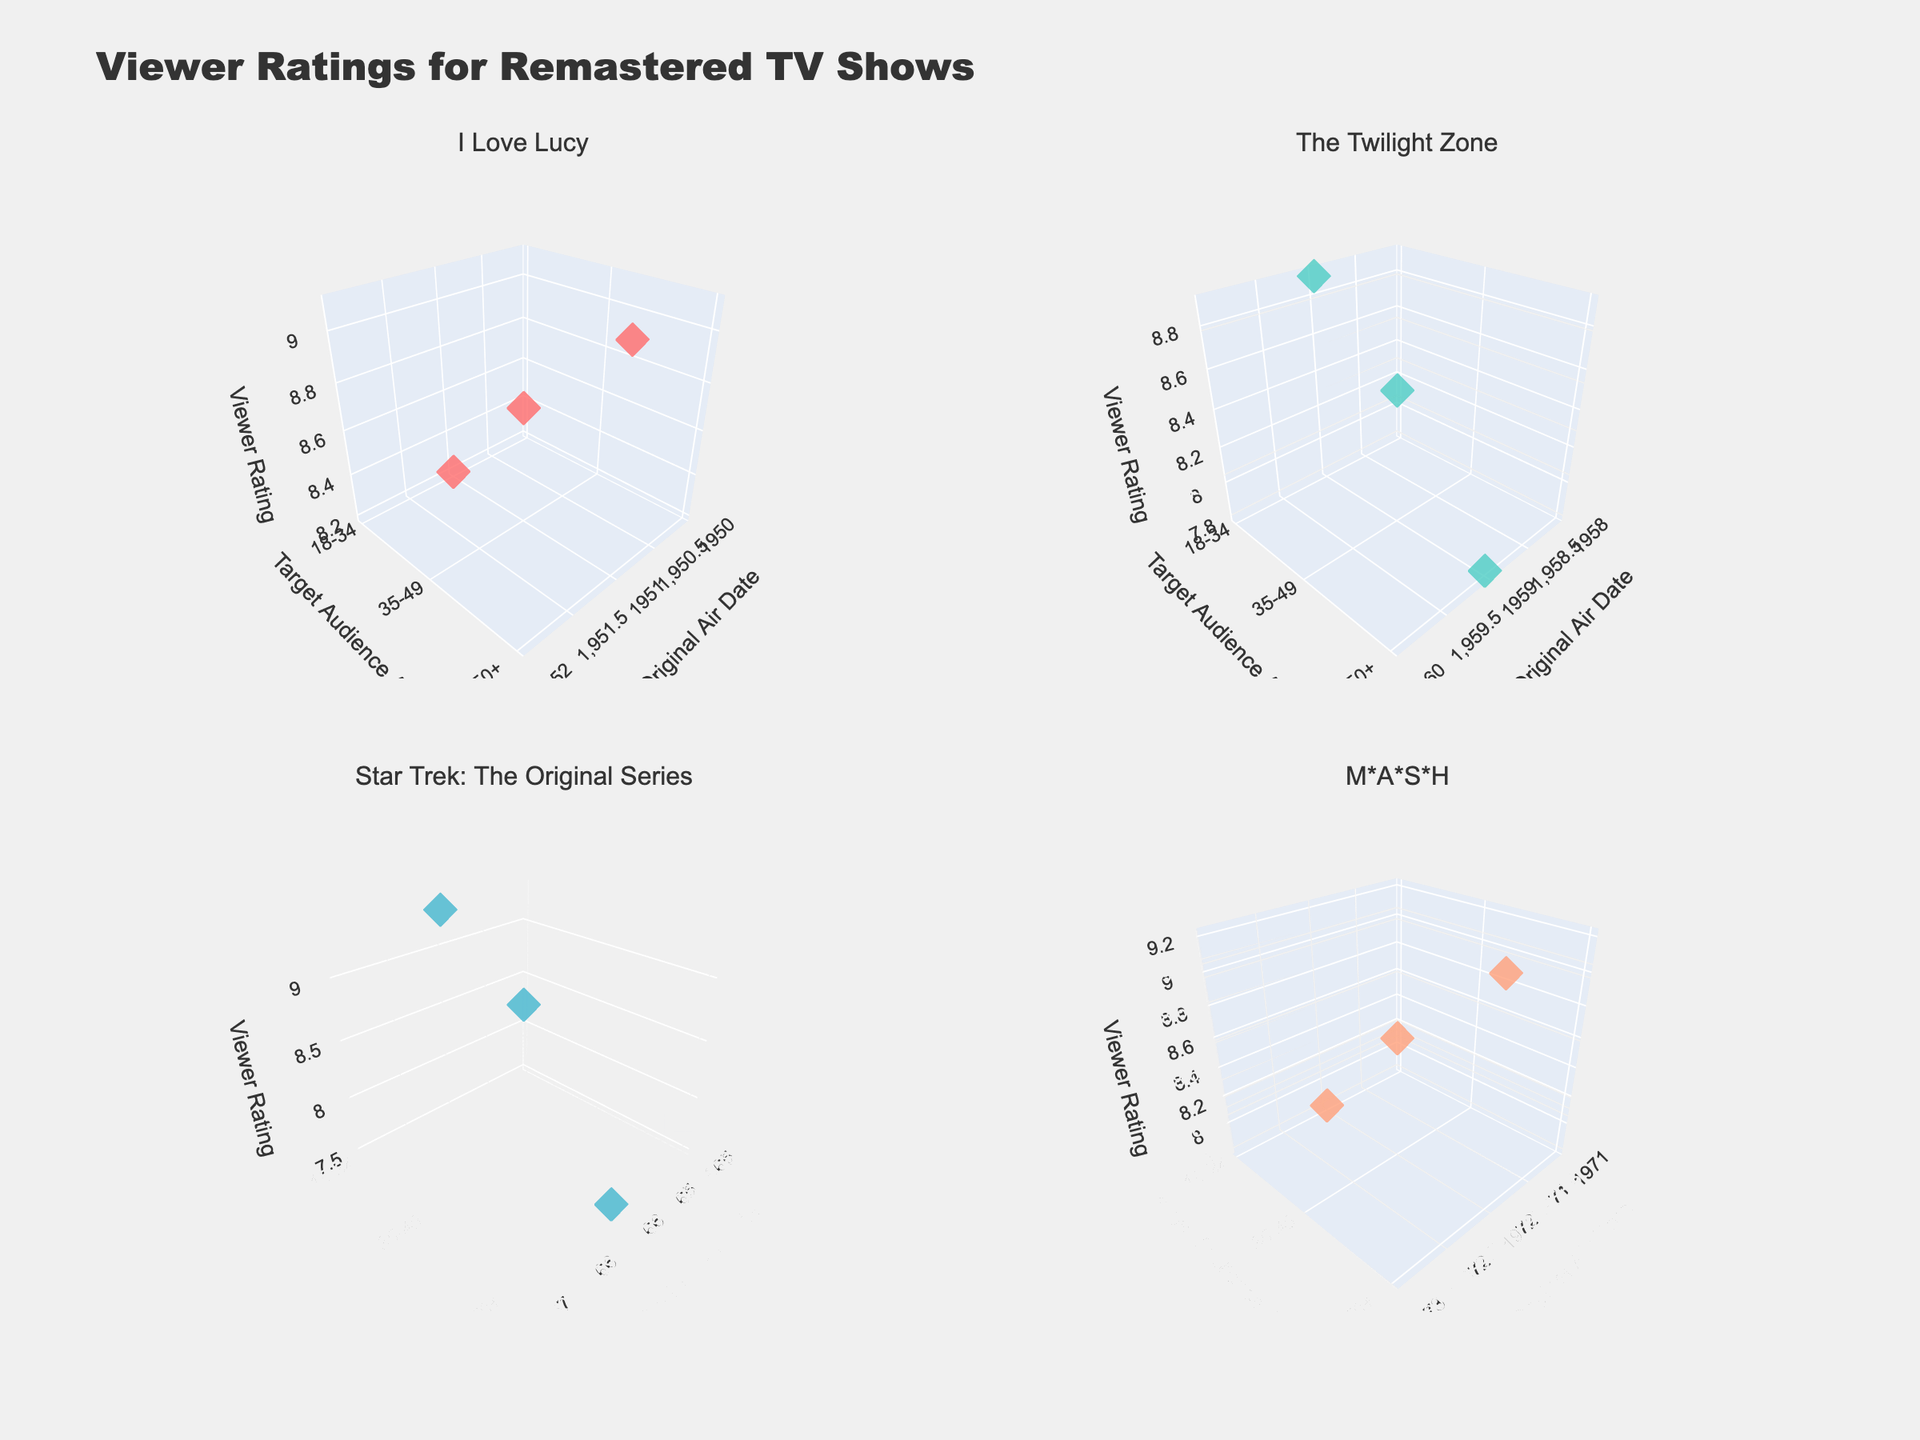What is the title of the figure? The title of the figure is usually displayed at the top. Here, it reads "Viewer Ratings for Remastered TV Shows".
Answer: Viewer Ratings for Remastered TV Shows Which show has the highest viewer rating among 18-34 age group? To find the highest rating in the 18-34 age group, look for the highest z-coordinate value (Viewer Rating) where y-coordinate (Target Audience Age) is 18-34. For shows plotted, Friends has the highest rating of 9.4.
Answer: Friends How many data points are plotted for each show in the figure? Each show has three data points, corresponding to the three age groups: 18-34, 35-49, and 50+. Count the markers for any show to confirm this.
Answer: 3 What's the average viewer rating of "I Love Lucy" across all age groups? Average is calculated by summing the ratings for "I Love Lucy" (8.2, 8.7, 9.1) and then dividing by the number of data points (3). The calculation is (8.2 + 8.7 + 9.1) / 3 = 26 / 3 = 8.67.
Answer: 8.67 Which age group gave "The Twilight Zone" the lowest rating? Identify the markers associated with "The Twilight Zone" and compare their z-values (Viewer Rating). The 50+ age group has the lowest rating of 7.8.
Answer: 50+ How does the viewer rating of "Cheers" for the 35-49 age group compare to its rating for the 50+ age group? To compare, locate the y-values (35-49 and 50+) for "Cheers" and compare their corresponding z-values (Viewer Rating). For 35-49 age group, it is 9.0, and for 50+ age group, it is 8.3. Thus, 35-49 age group rating is higher.
Answer: Higher What is the trend in viewer ratings for "M*A*S*H" as the target audience age increases? Observe the z-values (Viewer Rating) of "M*A*S*H" markers as the y-values (Target Audience Age) increase (18-34, 35-49, 50+). The ratings are 7.8, 8.6, and 9.2, showing an increasing trend.
Answer: Increasing Which show has the most consistent viewer ratings across different age groups? Consistency in ratings across age groups means minimal variation. Check the variance of ratings for each show. "I Love Lucy" ratings are 8.2, 8.7, and 9.1, showing the least variance.
Answer: I Love Lucy Compare the viewer ratings of "Star Trek: The Original Series" and "The X-Files" for the 50+ age group. Which one is higher? Locate the z-values (Viewer Rating) for "Star Trek" and "The X-Files" at the y-coordinate (50+ age group). "Star Trek" has a rating of 7.5, while "The X-Files" has a rating of 7.9, making "The X-Files" higher.
Answer: The X-Files What's the average viewer rating for shows aired in the 1990s across all age groups? Shows aired in the 1990s are "The X-Files" and "Friends". Sum their ratings across all age groups (9.1, 8.7, 7.9, 9.4, 8.9, 7.6) and divide by the number of data points (6). The calculation is (9.1 + 8.7 + 7.9 + 9.4 + 8.9 + 7.6) / 6 = 51.6 / 6 = 8.6.
Answer: 8.6 